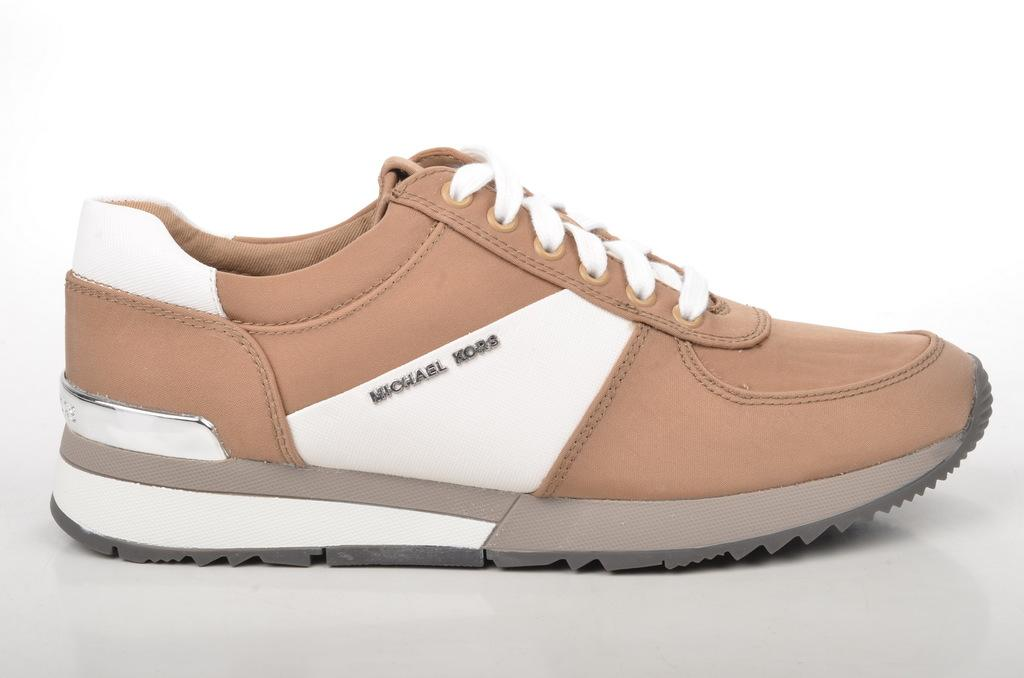What object is the main subject of the image? There is a shoe in the image. What color is the background of the image? The background of the image is white. Can you see the friend holding the receipt for the net in the image? There is no friend, receipt, or net present in the image; it only features a shoe against a white background. 